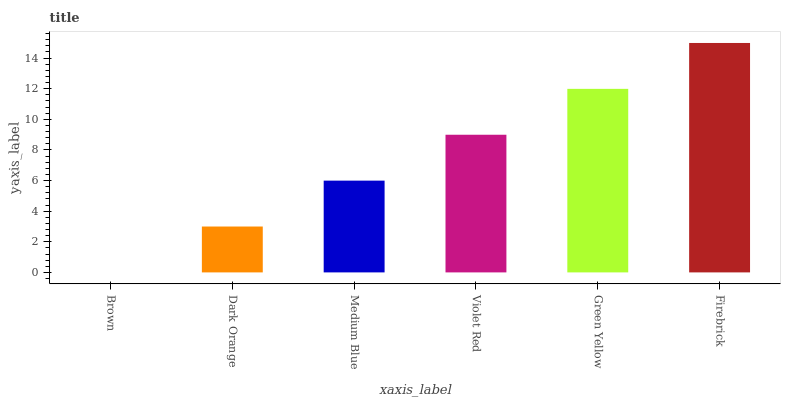Is Brown the minimum?
Answer yes or no. Yes. Is Firebrick the maximum?
Answer yes or no. Yes. Is Dark Orange the minimum?
Answer yes or no. No. Is Dark Orange the maximum?
Answer yes or no. No. Is Dark Orange greater than Brown?
Answer yes or no. Yes. Is Brown less than Dark Orange?
Answer yes or no. Yes. Is Brown greater than Dark Orange?
Answer yes or no. No. Is Dark Orange less than Brown?
Answer yes or no. No. Is Violet Red the high median?
Answer yes or no. Yes. Is Medium Blue the low median?
Answer yes or no. Yes. Is Brown the high median?
Answer yes or no. No. Is Firebrick the low median?
Answer yes or no. No. 